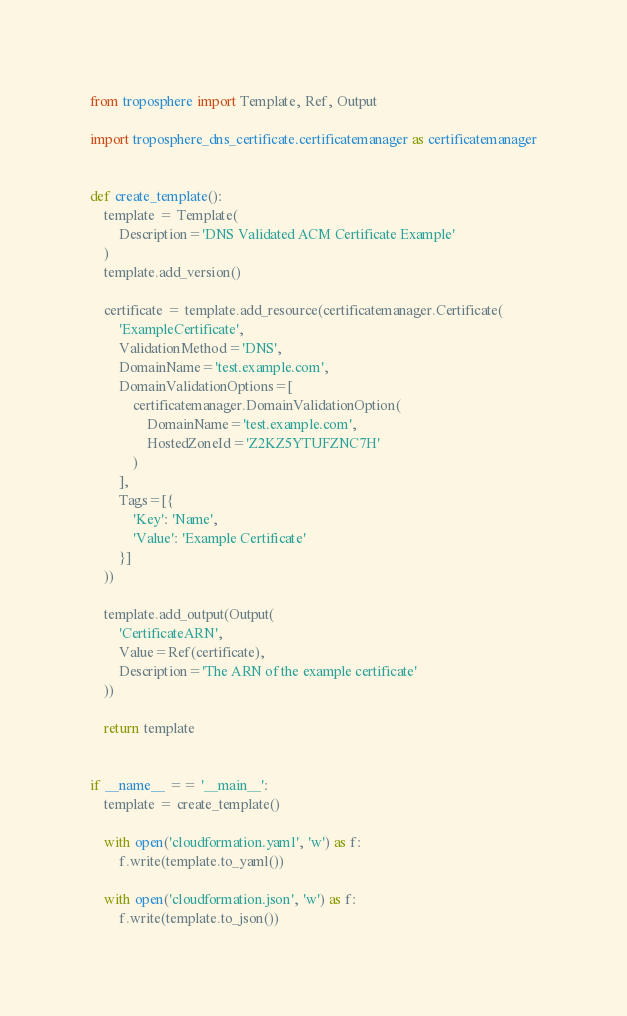<code> <loc_0><loc_0><loc_500><loc_500><_Python_>from troposphere import Template, Ref, Output

import troposphere_dns_certificate.certificatemanager as certificatemanager


def create_template():
    template = Template(
        Description='DNS Validated ACM Certificate Example'
    )
    template.add_version()

    certificate = template.add_resource(certificatemanager.Certificate(
        'ExampleCertificate',
        ValidationMethod='DNS',
        DomainName='test.example.com',
        DomainValidationOptions=[
            certificatemanager.DomainValidationOption(
                DomainName='test.example.com',
                HostedZoneId='Z2KZ5YTUFZNC7H'
            )
        ],
        Tags=[{
            'Key': 'Name',
            'Value': 'Example Certificate'
        }]
    ))

    template.add_output(Output(
        'CertificateARN',
        Value=Ref(certificate),
        Description='The ARN of the example certificate'
    ))

    return template


if __name__ == '__main__':
    template = create_template()

    with open('cloudformation.yaml', 'w') as f:
        f.write(template.to_yaml())

    with open('cloudformation.json', 'w') as f:
        f.write(template.to_json())
</code> 